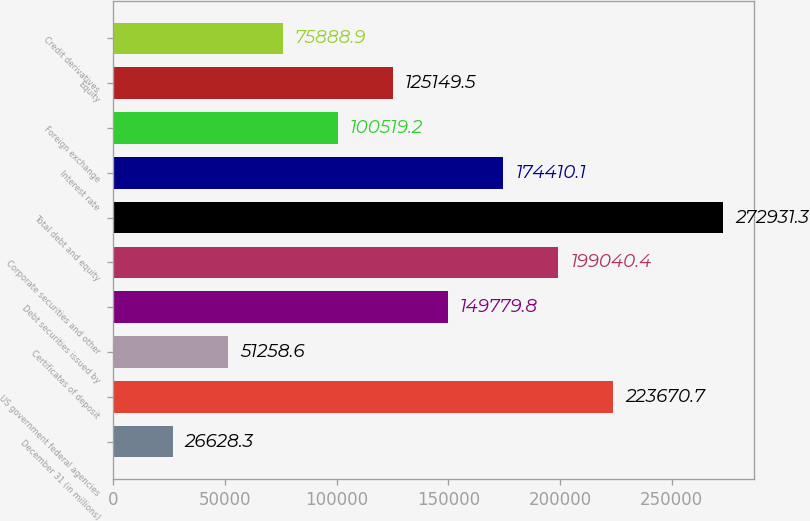Convert chart. <chart><loc_0><loc_0><loc_500><loc_500><bar_chart><fcel>December 31 (in millions)<fcel>US government federal agencies<fcel>Certificates of deposit<fcel>Debt securities issued by<fcel>Corporate securities and other<fcel>Total debt and equity<fcel>Interest rate<fcel>Foreign exchange<fcel>Equity<fcel>Credit derivatives<nl><fcel>26628.3<fcel>223671<fcel>51258.6<fcel>149780<fcel>199040<fcel>272931<fcel>174410<fcel>100519<fcel>125150<fcel>75888.9<nl></chart> 